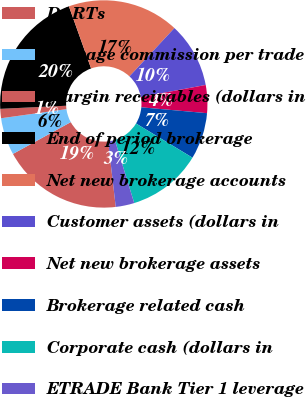<chart> <loc_0><loc_0><loc_500><loc_500><pie_chart><fcel>DARTs<fcel>Average commission per trade<fcel>Margin receivables (dollars in<fcel>End of period brokerage<fcel>Net new brokerage accounts<fcel>Customer assets (dollars in<fcel>Net new brokerage assets<fcel>Brokerage related cash<fcel>Corporate cash (dollars in<fcel>ETRADE Bank Tier 1 leverage<nl><fcel>18.84%<fcel>5.8%<fcel>1.45%<fcel>20.29%<fcel>17.39%<fcel>10.14%<fcel>4.35%<fcel>7.25%<fcel>11.59%<fcel>2.9%<nl></chart> 